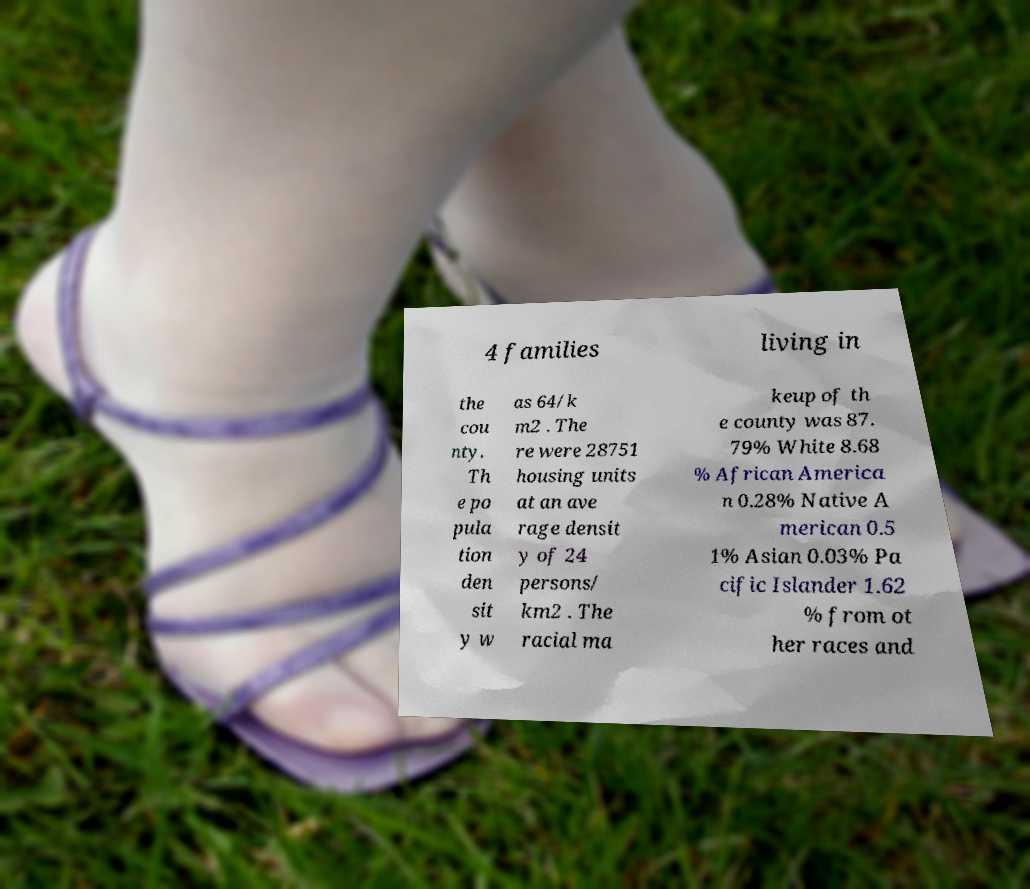There's text embedded in this image that I need extracted. Can you transcribe it verbatim? 4 families living in the cou nty. Th e po pula tion den sit y w as 64/k m2 . The re were 28751 housing units at an ave rage densit y of 24 persons/ km2 . The racial ma keup of th e county was 87. 79% White 8.68 % African America n 0.28% Native A merican 0.5 1% Asian 0.03% Pa cific Islander 1.62 % from ot her races and 